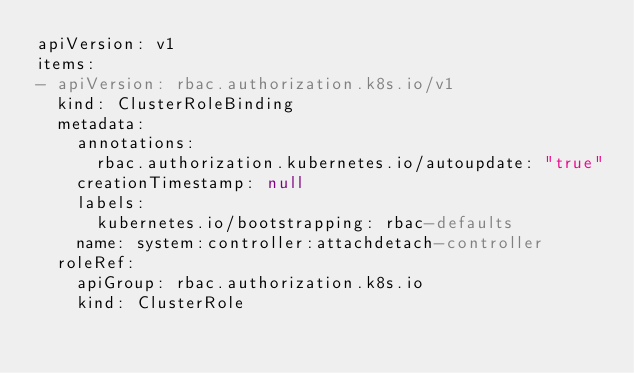<code> <loc_0><loc_0><loc_500><loc_500><_YAML_>apiVersion: v1
items:
- apiVersion: rbac.authorization.k8s.io/v1
  kind: ClusterRoleBinding
  metadata:
    annotations:
      rbac.authorization.kubernetes.io/autoupdate: "true"
    creationTimestamp: null
    labels:
      kubernetes.io/bootstrapping: rbac-defaults
    name: system:controller:attachdetach-controller
  roleRef:
    apiGroup: rbac.authorization.k8s.io
    kind: ClusterRole</code> 